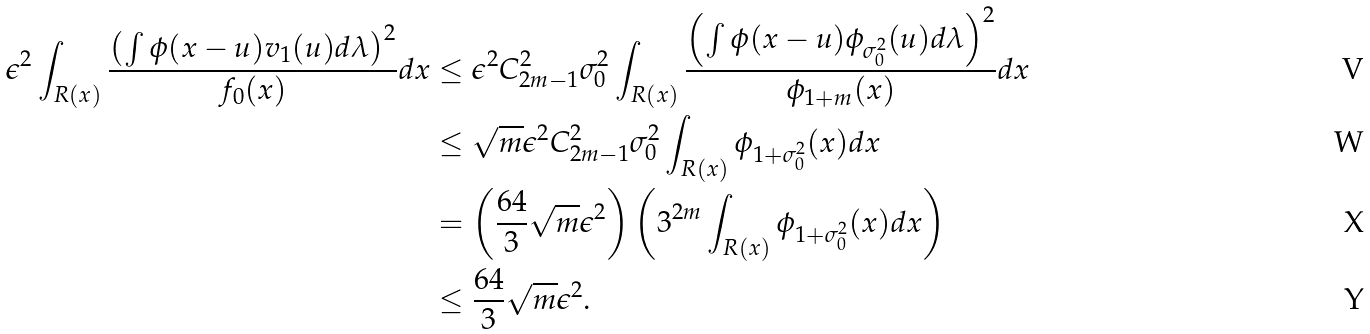Convert formula to latex. <formula><loc_0><loc_0><loc_500><loc_500>\epsilon ^ { 2 } \int _ { R ( x ) } \frac { \left ( \int \phi ( x - u ) v _ { 1 } ( u ) d \lambda \right ) ^ { 2 } } { f _ { 0 } ( x ) } d x & \leq \epsilon ^ { 2 } C _ { 2 m - 1 } ^ { 2 } \sigma _ { 0 } ^ { 2 } \int _ { R ( x ) } \frac { \left ( \int \phi ( x - u ) \phi _ { \sigma _ { 0 } ^ { 2 } } ( u ) d \lambda \right ) ^ { 2 } } { \phi _ { 1 + m } ( x ) } d x \\ & \leq \sqrt { m } \epsilon ^ { 2 } C _ { 2 m - 1 } ^ { 2 } \sigma _ { 0 } ^ { 2 } \int _ { R ( x ) } \phi _ { 1 + \sigma _ { 0 } ^ { 2 } } ( x ) d x \\ & = \left ( \frac { 6 4 } { 3 } \sqrt { m } \epsilon ^ { 2 } \right ) \left ( 3 ^ { 2 m } \int _ { R ( x ) } \phi _ { 1 + \sigma _ { 0 } ^ { 2 } } ( x ) d x \right ) \\ & \leq \frac { 6 4 } { 3 } \sqrt { m } \epsilon ^ { 2 } .</formula> 